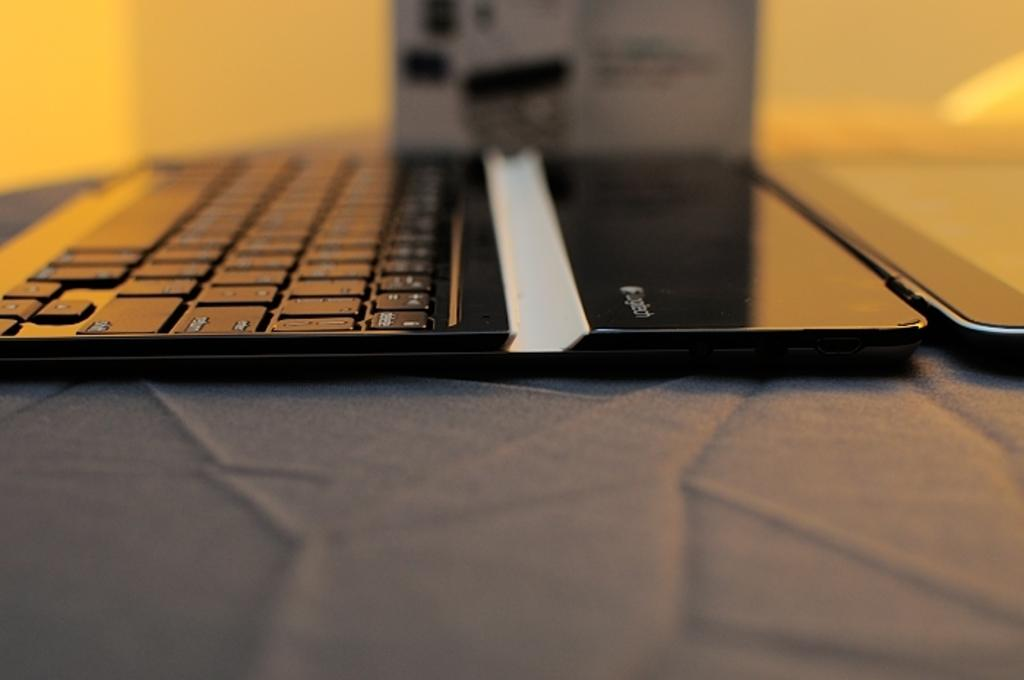What electronic device is visible in the image? There is a laptop in the image. How many bricks are stacked on top of the laptop in the image? There are no bricks present in the image; it only features a laptop. Is there a girl using the laptop in the image? The image does not show a girl or any other person using the laptop. Are there any berries placed on the laptop in the image? There are no berries present in the image; it only features a laptop. 